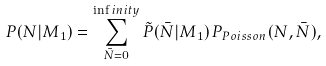Convert formula to latex. <formula><loc_0><loc_0><loc_500><loc_500>P ( N | M _ { 1 } ) = \sum _ { \bar { N } = 0 } ^ { \inf i n i t y } \tilde { P } ( \bar { N } | M _ { 1 } ) \, P _ { P o i s s o n } ( N , \bar { N } ) ,</formula> 